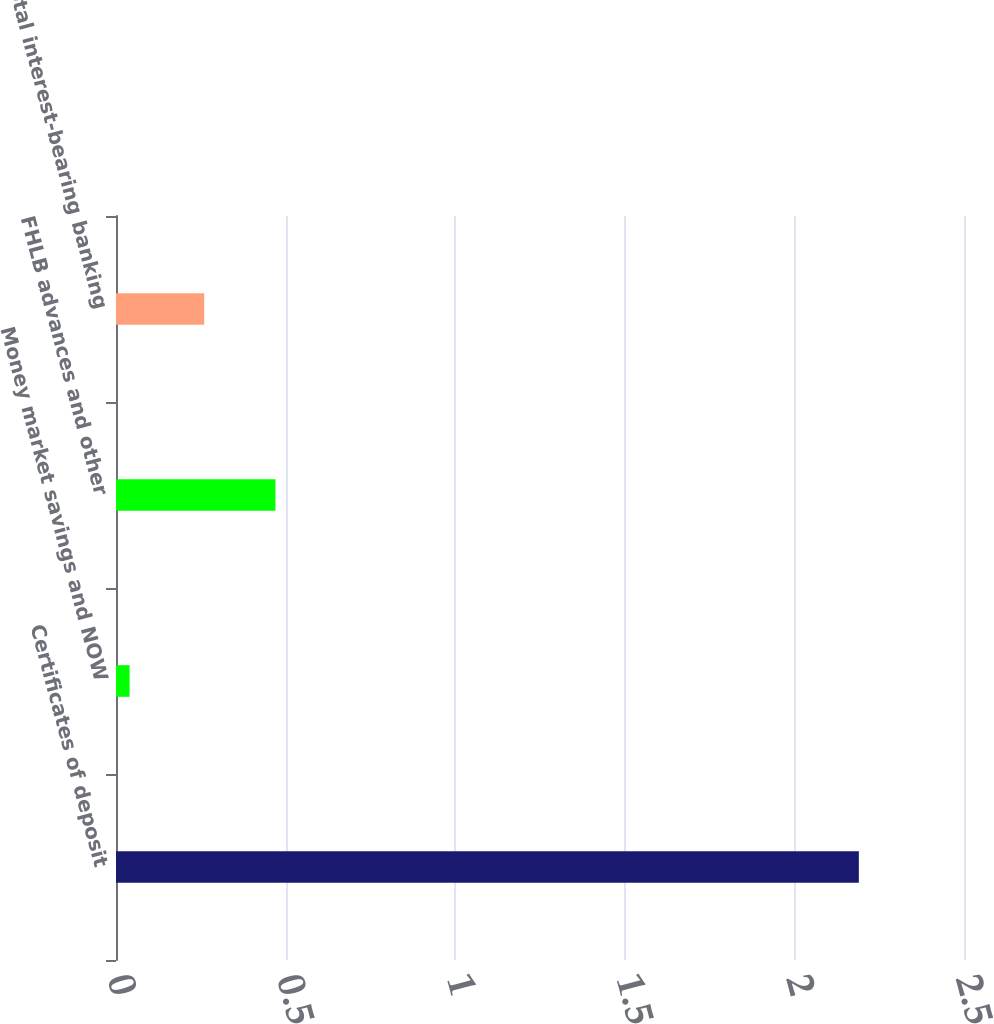Convert chart. <chart><loc_0><loc_0><loc_500><loc_500><bar_chart><fcel>Certificates of deposit<fcel>Money market savings and NOW<fcel>FHLB advances and other<fcel>Total interest-bearing banking<nl><fcel>2.19<fcel>0.04<fcel>0.47<fcel>0.26<nl></chart> 